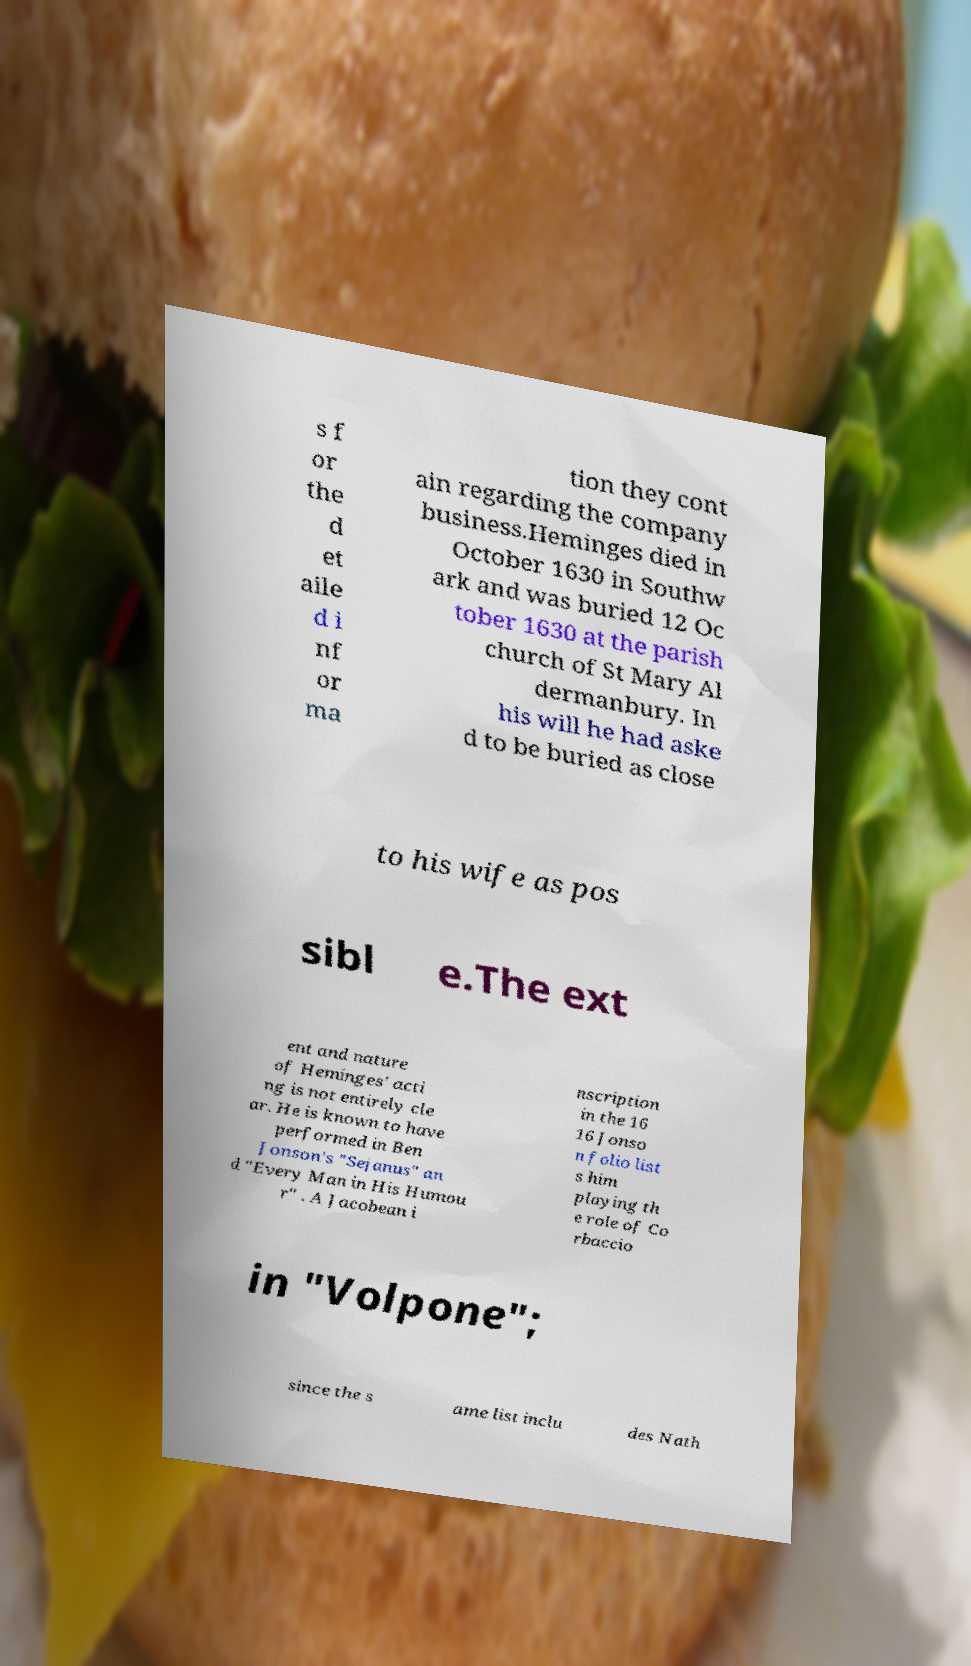For documentation purposes, I need the text within this image transcribed. Could you provide that? s f or the d et aile d i nf or ma tion they cont ain regarding the company business.Heminges died in October 1630 in Southw ark and was buried 12 Oc tober 1630 at the parish church of St Mary Al dermanbury. In his will he had aske d to be buried as close to his wife as pos sibl e.The ext ent and nature of Heminges' acti ng is not entirely cle ar. He is known to have performed in Ben Jonson's "Sejanus" an d "Every Man in His Humou r" . A Jacobean i nscription in the 16 16 Jonso n folio list s him playing th e role of Co rbaccio in "Volpone"; since the s ame list inclu des Nath 